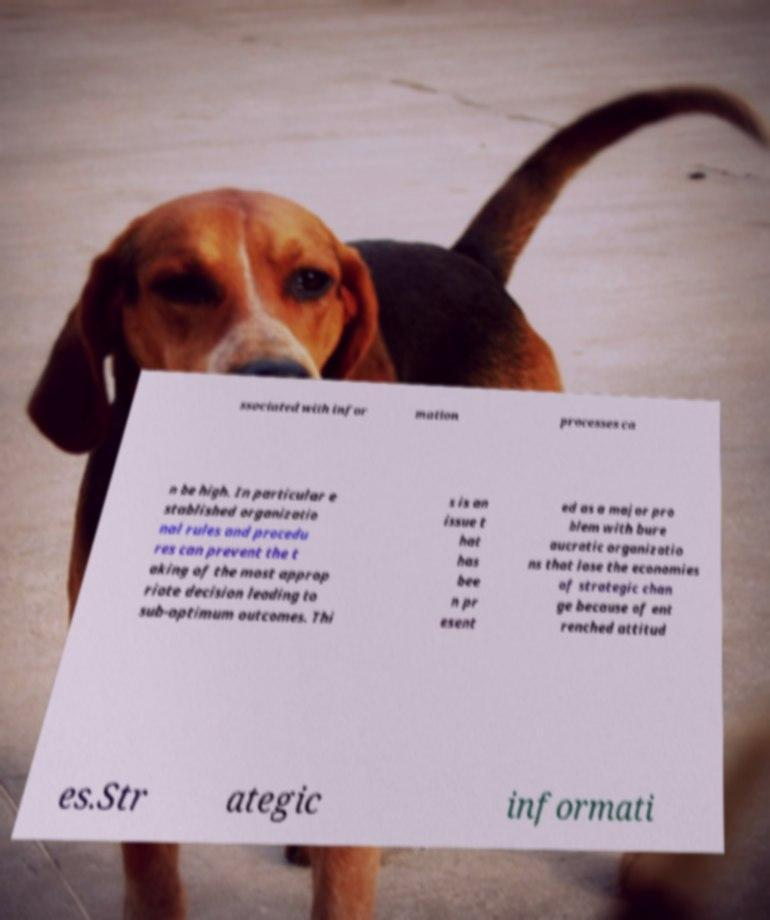Can you accurately transcribe the text from the provided image for me? ssociated with infor mation processes ca n be high. In particular e stablished organizatio nal rules and procedu res can prevent the t aking of the most approp riate decision leading to sub-optimum outcomes. Thi s is an issue t hat has bee n pr esent ed as a major pro blem with bure aucratic organizatio ns that lose the economies of strategic chan ge because of ent renched attitud es.Str ategic informati 